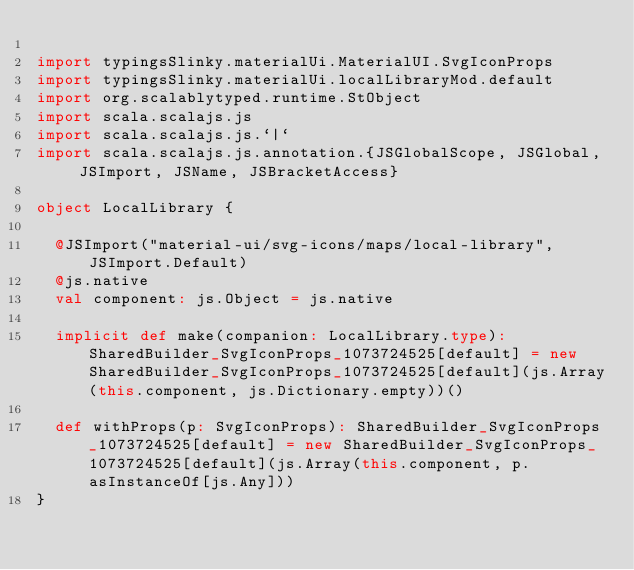Convert code to text. <code><loc_0><loc_0><loc_500><loc_500><_Scala_>
import typingsSlinky.materialUi.MaterialUI.SvgIconProps
import typingsSlinky.materialUi.localLibraryMod.default
import org.scalablytyped.runtime.StObject
import scala.scalajs.js
import scala.scalajs.js.`|`
import scala.scalajs.js.annotation.{JSGlobalScope, JSGlobal, JSImport, JSName, JSBracketAccess}

object LocalLibrary {
  
  @JSImport("material-ui/svg-icons/maps/local-library", JSImport.Default)
  @js.native
  val component: js.Object = js.native
  
  implicit def make(companion: LocalLibrary.type): SharedBuilder_SvgIconProps_1073724525[default] = new SharedBuilder_SvgIconProps_1073724525[default](js.Array(this.component, js.Dictionary.empty))()
  
  def withProps(p: SvgIconProps): SharedBuilder_SvgIconProps_1073724525[default] = new SharedBuilder_SvgIconProps_1073724525[default](js.Array(this.component, p.asInstanceOf[js.Any]))
}
</code> 